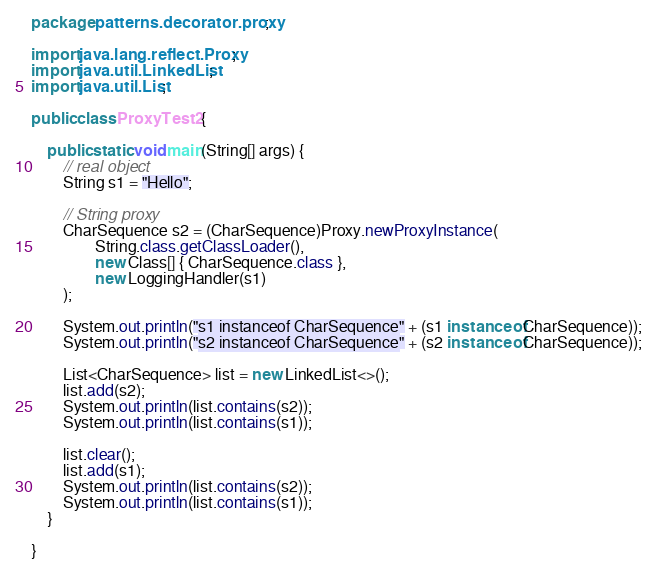Convert code to text. <code><loc_0><loc_0><loc_500><loc_500><_Java_>package patterns.decorator.proxy;

import java.lang.reflect.Proxy;
import java.util.LinkedList;
import java.util.List;

public class ProxyTest2 {

	public static void main(String[] args) {
		// real object
		String s1 = "Hello";
		
		// String proxy
		CharSequence s2 = (CharSequence)Proxy.newProxyInstance(
				String.class.getClassLoader(),
				new Class[] { CharSequence.class },
				new LoggingHandler(s1)
		);

		System.out.println("s1 instanceof CharSequence" + (s1 instanceof CharSequence));
		System.out.println("s2 instanceof CharSequence" + (s2 instanceof CharSequence));

		List<CharSequence> list = new LinkedList<>();
		list.add(s2);
		System.out.println(list.contains(s2));
		System.out.println(list.contains(s1));

		list.clear();
		list.add(s1);
		System.out.println(list.contains(s2));
		System.out.println(list.contains(s1));
	}

}
</code> 